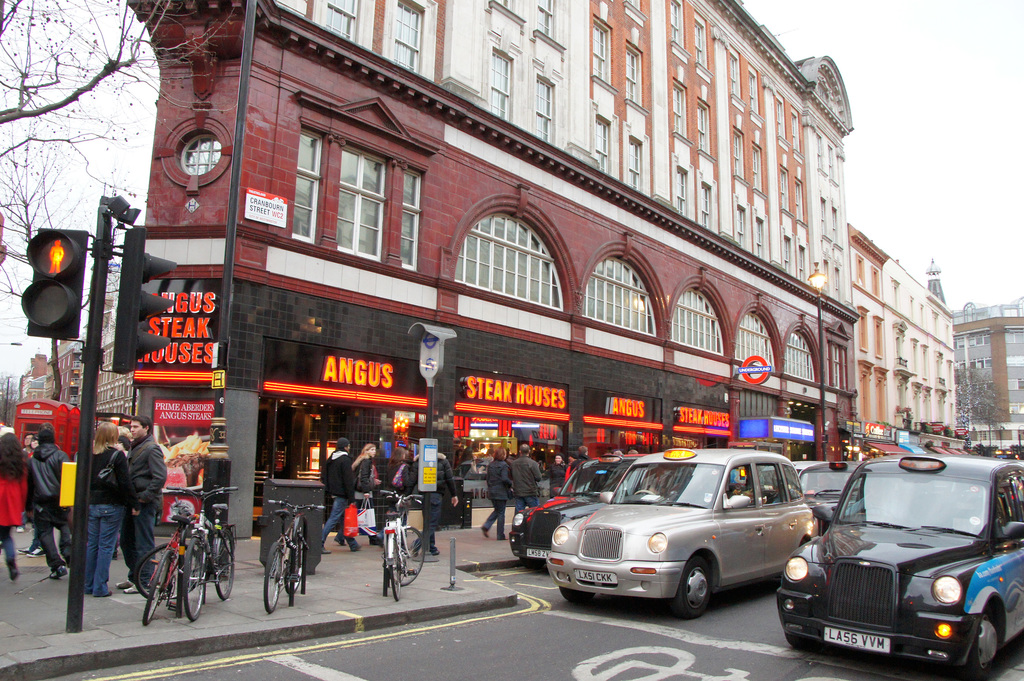What types of transportation are visible in the image and what does this suggest about the location? The image shows several modes of transportation including bicycles, black taxis, and a glimpse of what appears to be a subway entrance, suggesting the scene is set in a well-connected urban center, likely London, where public and private transportation options are readily available for city dwellers and visitors. 